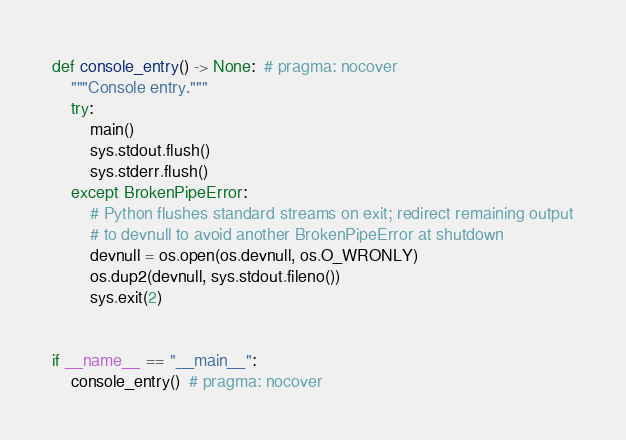<code> <loc_0><loc_0><loc_500><loc_500><_Python_>
def console_entry() -> None:  # pragma: nocover
    """Console entry."""
    try:
        main()
        sys.stdout.flush()
        sys.stderr.flush()
    except BrokenPipeError:
        # Python flushes standard streams on exit; redirect remaining output
        # to devnull to avoid another BrokenPipeError at shutdown
        devnull = os.open(os.devnull, os.O_WRONLY)
        os.dup2(devnull, sys.stdout.fileno())
        sys.exit(2)


if __name__ == "__main__":
    console_entry()  # pragma: nocover
</code> 